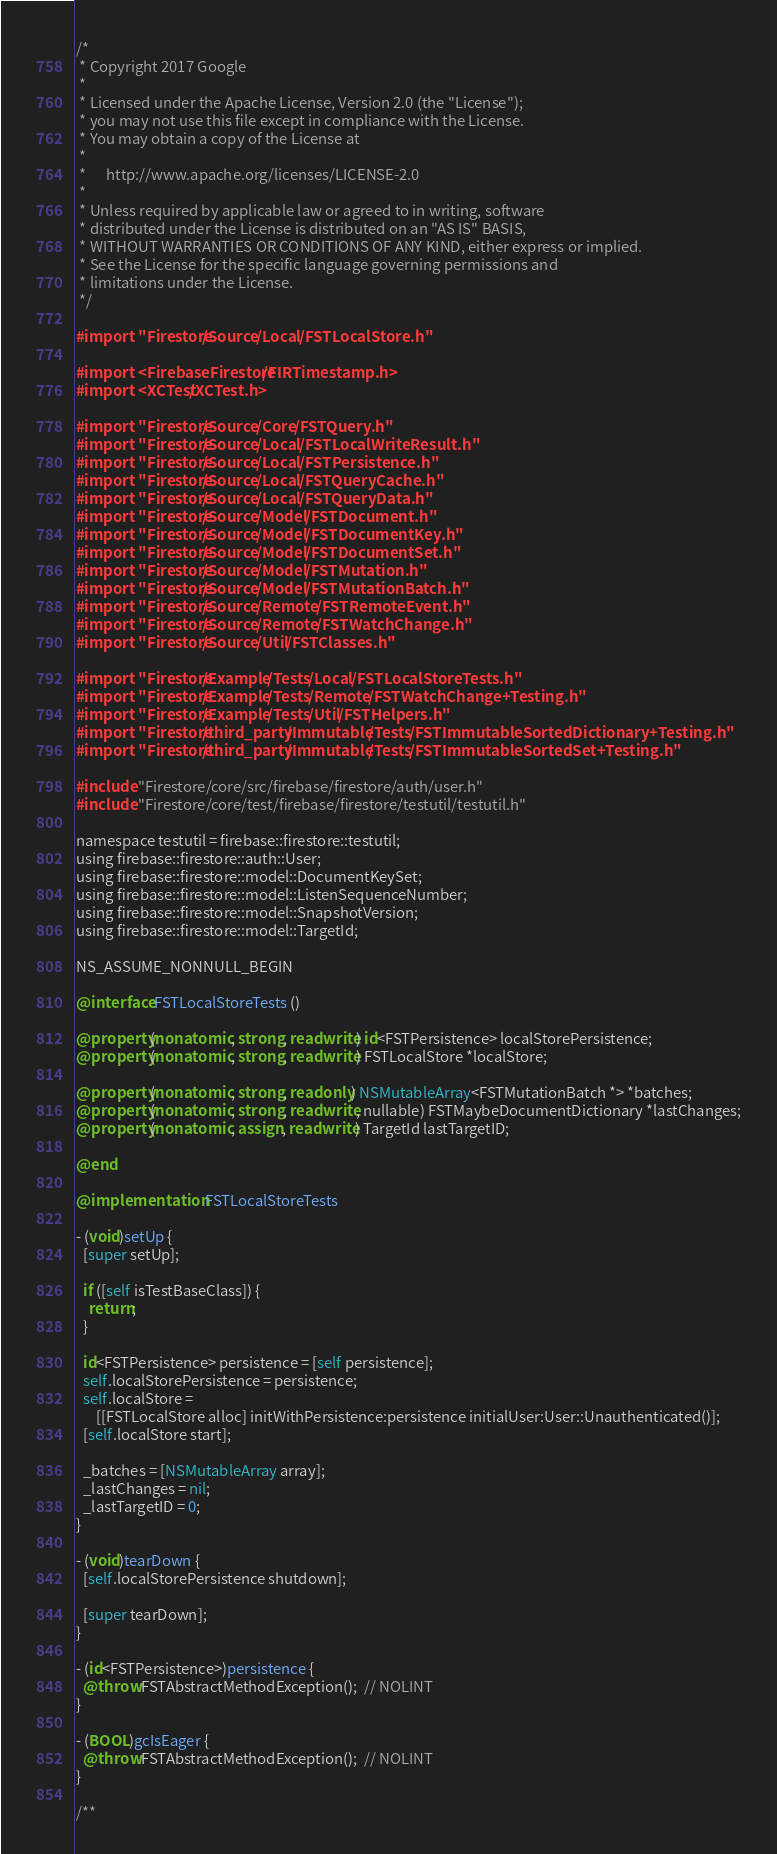<code> <loc_0><loc_0><loc_500><loc_500><_ObjectiveC_>/*
 * Copyright 2017 Google
 *
 * Licensed under the Apache License, Version 2.0 (the "License");
 * you may not use this file except in compliance with the License.
 * You may obtain a copy of the License at
 *
 *      http://www.apache.org/licenses/LICENSE-2.0
 *
 * Unless required by applicable law or agreed to in writing, software
 * distributed under the License is distributed on an "AS IS" BASIS,
 * WITHOUT WARRANTIES OR CONDITIONS OF ANY KIND, either express or implied.
 * See the License for the specific language governing permissions and
 * limitations under the License.
 */

#import "Firestore/Source/Local/FSTLocalStore.h"

#import <FirebaseFirestore/FIRTimestamp.h>
#import <XCTest/XCTest.h>

#import "Firestore/Source/Core/FSTQuery.h"
#import "Firestore/Source/Local/FSTLocalWriteResult.h"
#import "Firestore/Source/Local/FSTPersistence.h"
#import "Firestore/Source/Local/FSTQueryCache.h"
#import "Firestore/Source/Local/FSTQueryData.h"
#import "Firestore/Source/Model/FSTDocument.h"
#import "Firestore/Source/Model/FSTDocumentKey.h"
#import "Firestore/Source/Model/FSTDocumentSet.h"
#import "Firestore/Source/Model/FSTMutation.h"
#import "Firestore/Source/Model/FSTMutationBatch.h"
#import "Firestore/Source/Remote/FSTRemoteEvent.h"
#import "Firestore/Source/Remote/FSTWatchChange.h"
#import "Firestore/Source/Util/FSTClasses.h"

#import "Firestore/Example/Tests/Local/FSTLocalStoreTests.h"
#import "Firestore/Example/Tests/Remote/FSTWatchChange+Testing.h"
#import "Firestore/Example/Tests/Util/FSTHelpers.h"
#import "Firestore/third_party/Immutable/Tests/FSTImmutableSortedDictionary+Testing.h"
#import "Firestore/third_party/Immutable/Tests/FSTImmutableSortedSet+Testing.h"

#include "Firestore/core/src/firebase/firestore/auth/user.h"
#include "Firestore/core/test/firebase/firestore/testutil/testutil.h"

namespace testutil = firebase::firestore::testutil;
using firebase::firestore::auth::User;
using firebase::firestore::model::DocumentKeySet;
using firebase::firestore::model::ListenSequenceNumber;
using firebase::firestore::model::SnapshotVersion;
using firebase::firestore::model::TargetId;

NS_ASSUME_NONNULL_BEGIN

@interface FSTLocalStoreTests ()

@property(nonatomic, strong, readwrite) id<FSTPersistence> localStorePersistence;
@property(nonatomic, strong, readwrite) FSTLocalStore *localStore;

@property(nonatomic, strong, readonly) NSMutableArray<FSTMutationBatch *> *batches;
@property(nonatomic, strong, readwrite, nullable) FSTMaybeDocumentDictionary *lastChanges;
@property(nonatomic, assign, readwrite) TargetId lastTargetID;

@end

@implementation FSTLocalStoreTests

- (void)setUp {
  [super setUp];

  if ([self isTestBaseClass]) {
    return;
  }

  id<FSTPersistence> persistence = [self persistence];
  self.localStorePersistence = persistence;
  self.localStore =
      [[FSTLocalStore alloc] initWithPersistence:persistence initialUser:User::Unauthenticated()];
  [self.localStore start];

  _batches = [NSMutableArray array];
  _lastChanges = nil;
  _lastTargetID = 0;
}

- (void)tearDown {
  [self.localStorePersistence shutdown];

  [super tearDown];
}

- (id<FSTPersistence>)persistence {
  @throw FSTAbstractMethodException();  // NOLINT
}

- (BOOL)gcIsEager {
  @throw FSTAbstractMethodException();  // NOLINT
}

/**</code> 